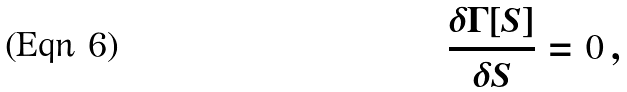Convert formula to latex. <formula><loc_0><loc_0><loc_500><loc_500>\frac { \delta \Gamma [ S ] } { \delta S } = 0 \, ,</formula> 